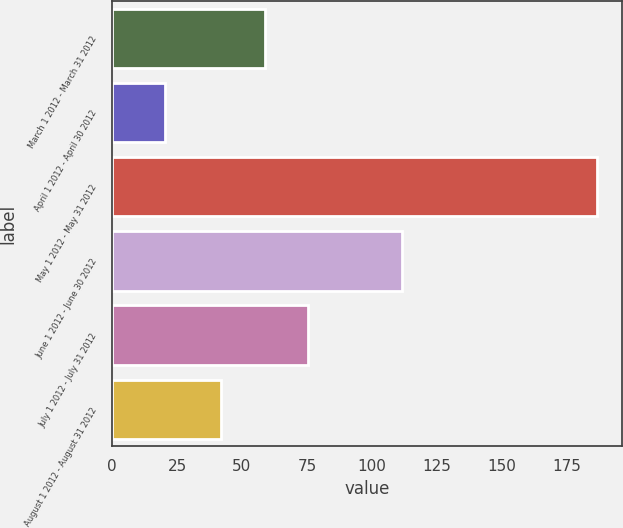Convert chart to OTSL. <chart><loc_0><loc_0><loc_500><loc_500><bar_chart><fcel>March 1 2012 - March 31 2012<fcel>April 1 2012 - April 30 2012<fcel>May 1 2012 - May 31 2012<fcel>June 1 2012 - June 30 2012<fcel>July 1 2012 - July 31 2012<fcel>August 1 2012 - August 31 2012<nl><fcel>58.75<fcel>20.4<fcel>186.9<fcel>111.5<fcel>75.4<fcel>42.1<nl></chart> 